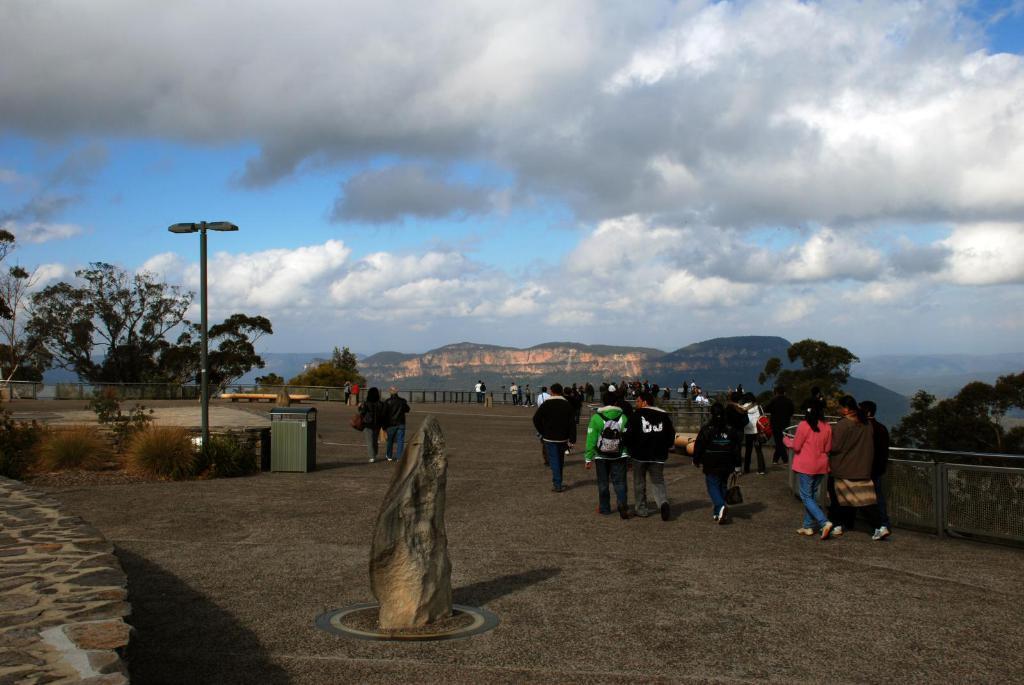Please provide a concise description of this image. This image is taken outdoors. At the top of the image there is the sky with clouds. At the bottom of the image there is a floor. In the background there are a few hills. There are a few trees. There is a railing. On the left side of the image there are a few plants and there is a pole with a street light. There is a dustbin on the road. In the middle of the image many people are walking on the road and there is an architecture. 